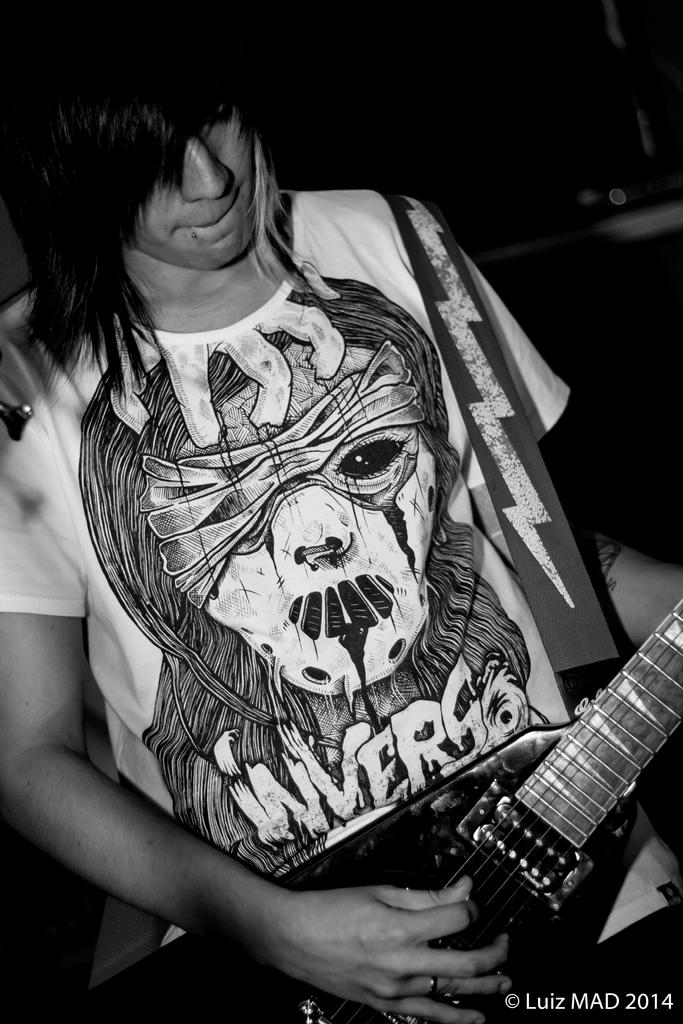What is the main subject of the image? There is a man in the image. What is the man doing in the image? The man is playing a guitar. What type of drum can be seen in the image? There is no drum present in the image; the man is playing a guitar. Is the man sliding down a slope in the image? There is no slope present in the image, and the man is playing a guitar while standing still. 